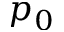<formula> <loc_0><loc_0><loc_500><loc_500>p _ { 0 }</formula> 